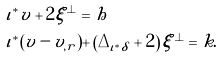Convert formula to latex. <formula><loc_0><loc_0><loc_500><loc_500>& \iota ^ { * } v + 2 \xi ^ { \perp } = h \\ & \iota ^ { * } ( v - v _ { , r } ) + \left ( \Delta _ { \iota ^ { * } \delta } + 2 \right ) \xi ^ { \perp } = k .</formula> 